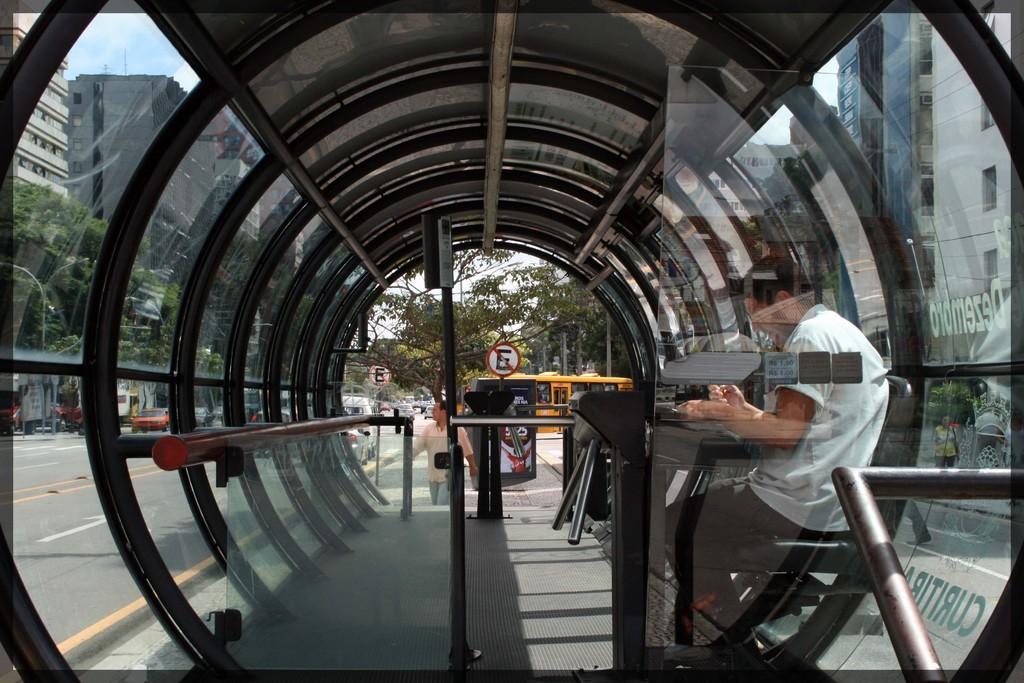Describe this image in one or two sentences. In this image, we can see a modern bus stop. There is a person in the bottom right of the image sitting on the chair. There are buildings on the left and on the right side of the image. There are trees beside the road. 